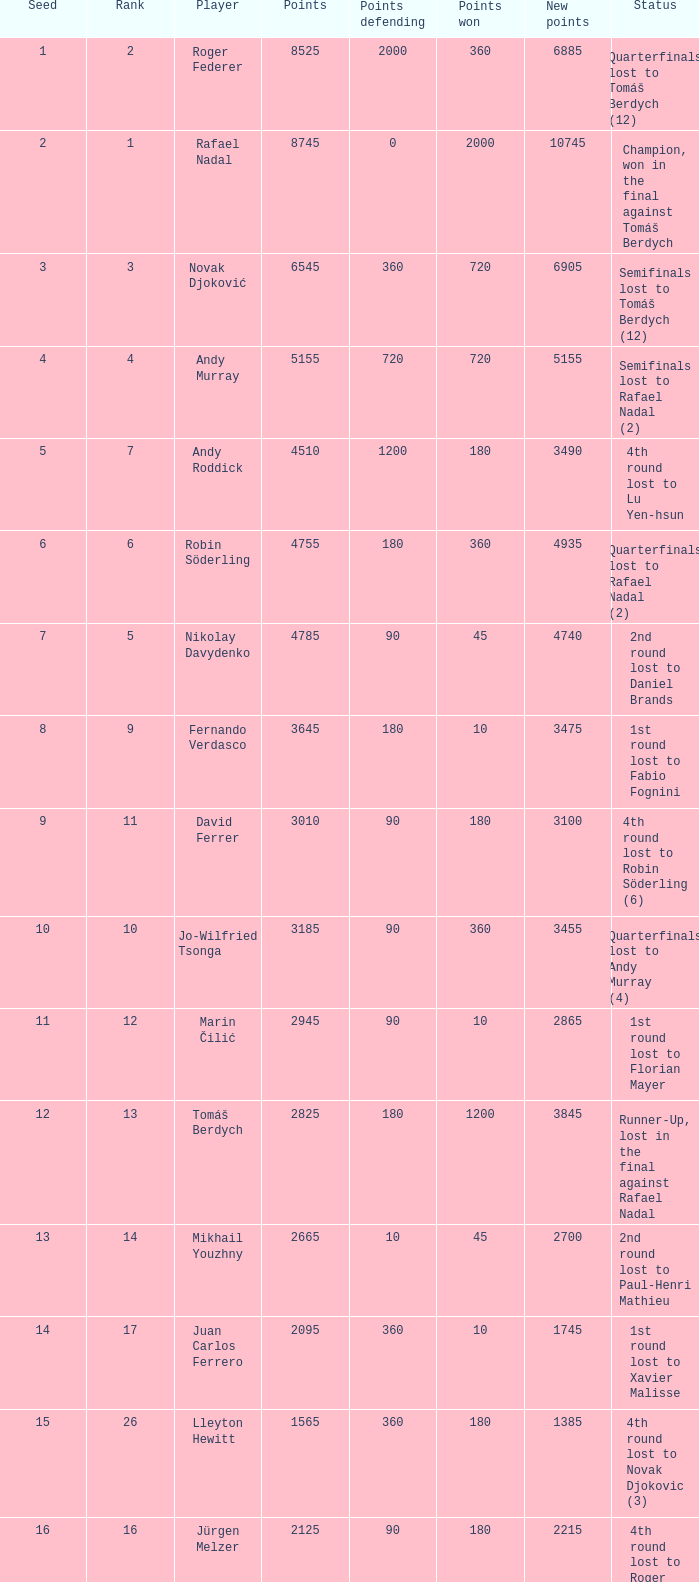Name the points won for 1230 90.0. 